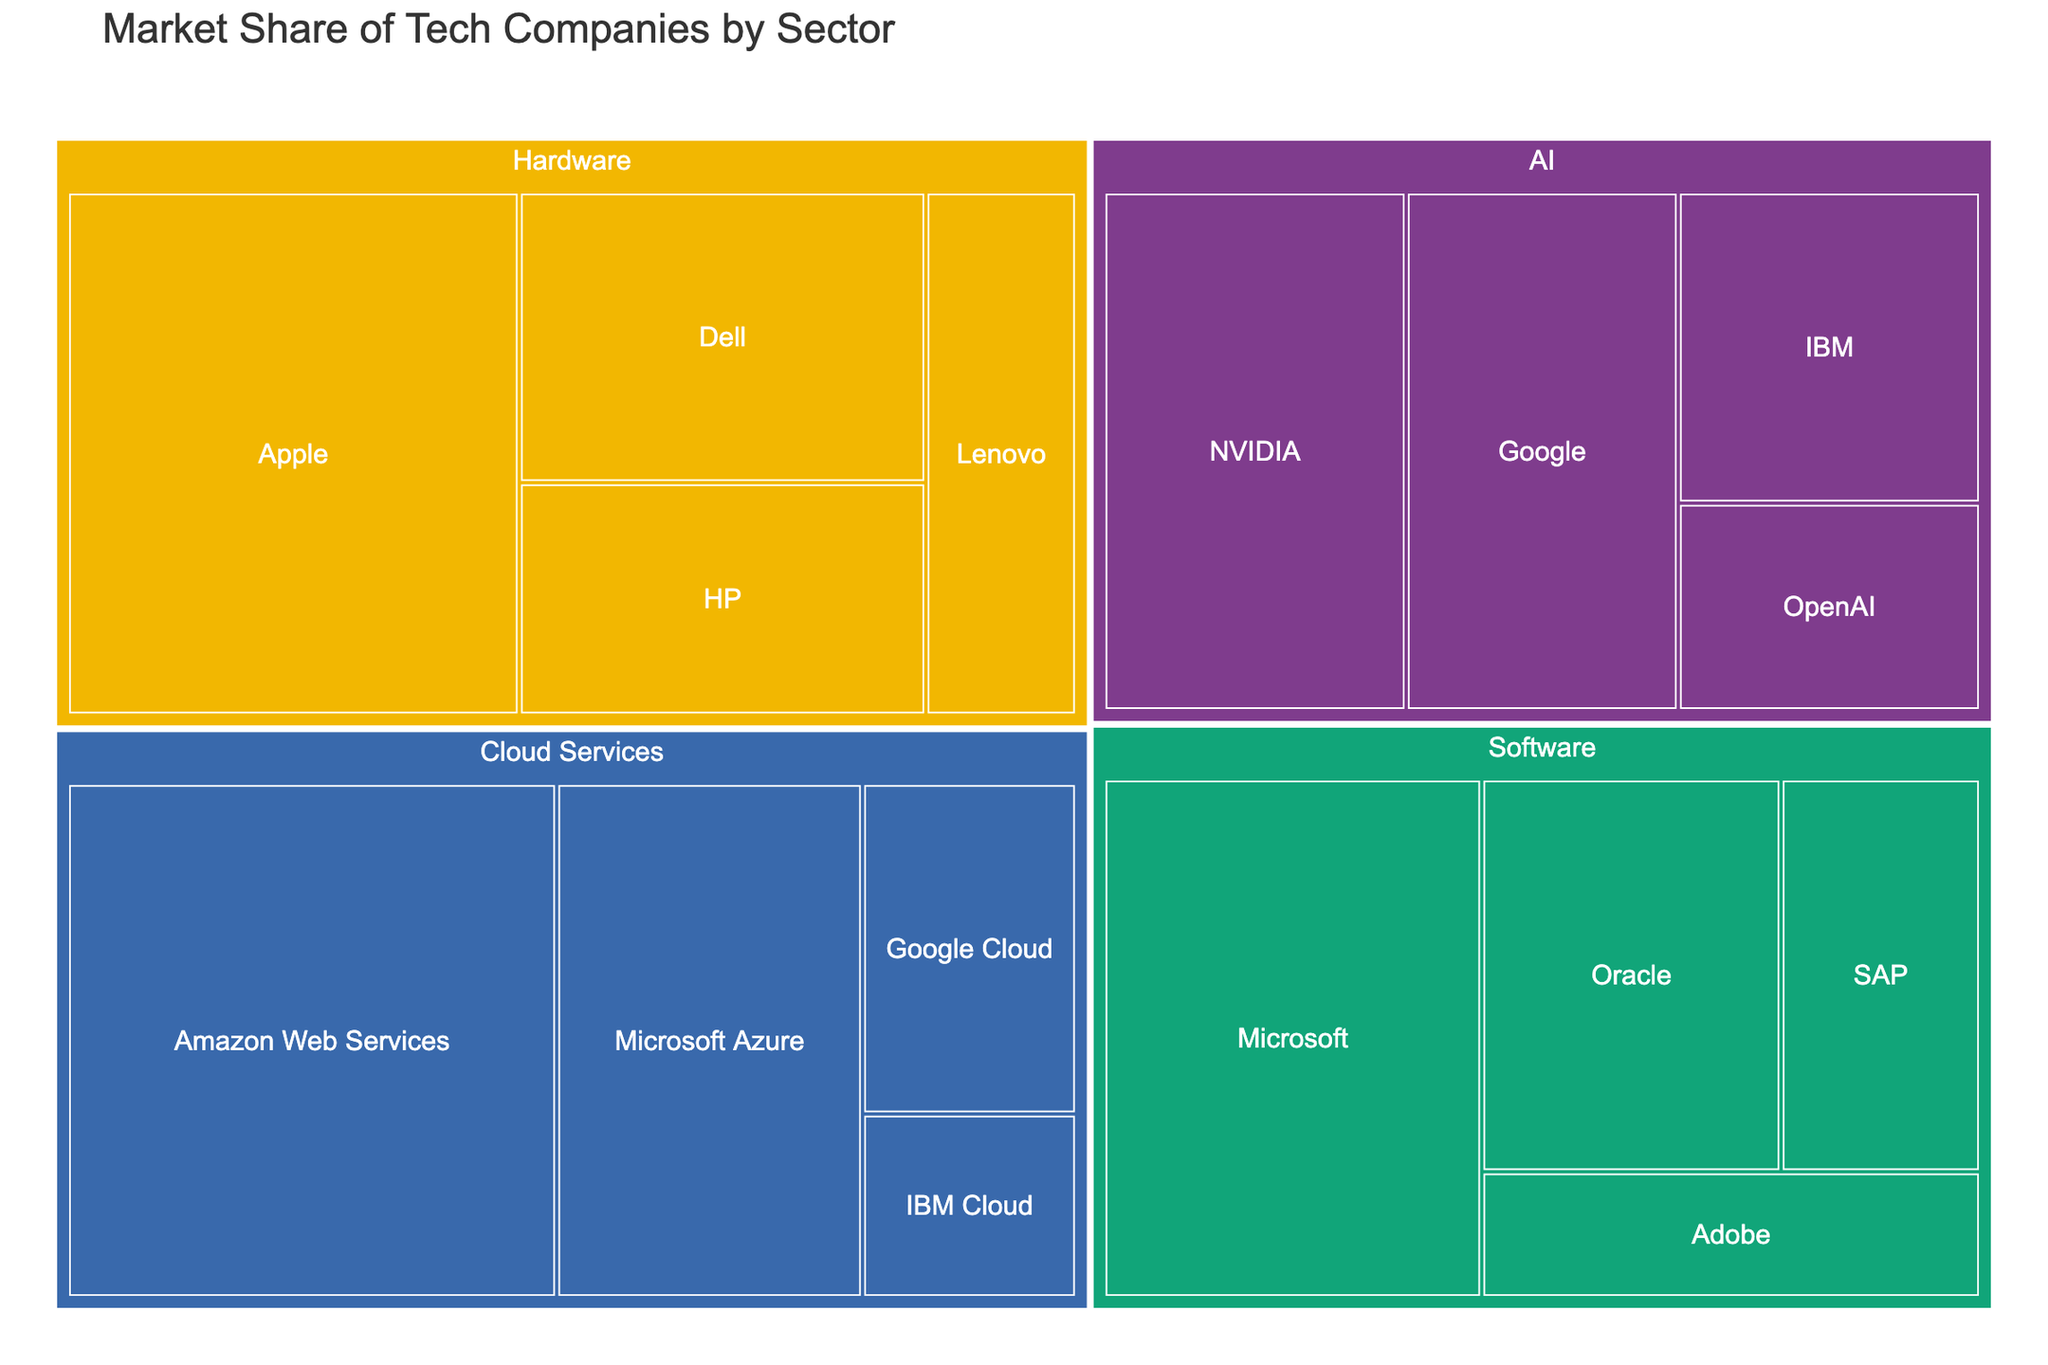what is the title of the plot? The title is often found at the top of the plot and indicates what the plot is about. Here, it is "Market Share of Tech Companies by Sector".
Answer: Market Share of Tech Companies by Sector which company has the largest market share in the AI sector? Look for the AI sector in the treemap and then identify the company with the largest area within that sector. The company is NVIDIA with a 20% market share.
Answer: NVIDIA what is the combined market share of Apple and Dell in the Hardware sector? Locate the Hardware sector and identify the market shares of Apple (30%) and Dell (15%). Add these values together: 30% + 15% = 45%.
Answer: 45% which sector has the most companies represented? Count the number of companies in each sector. Software has four companies (Microsoft, Oracle, SAP, Adobe), which is the highest.
Answer: Software which company has a greater market share: Google Cloud or OpenAI? Compare the market shares of Google Cloud (9%) in Cloud Services and OpenAI (8%) in AI. Google Cloud has a greater market share.
Answer: Google Cloud how does Microsoft’s market share in Software compare to its market share in Cloud Services? Find Microsoft's market share in Software (25%) and compare it to its market share in Cloud Services (20%). Microsoft's market share in Software is higher.
Answer: Higher in Software what is the combined market share of all companies in the Cloud Services sector? Locate the Cloud Services sector and sum the market shares of Amazon Web Services (32%), Microsoft Azure (20%), Google Cloud (9%), and IBM Cloud (5%). The total is: 32% + 20% + 9% + 5% = 66%.
Answer: 66% is OpenAI's market share in the AI sector higher or lower than IBM's? Compare the market shares of OpenAI (8%) and IBM (12%) in the AI sector. OpenAI's market share is lower.
Answer: Lower which two companies have the closest market share in the Hardware sector? Compare the market shares within the Hardware sector: Apple (30%), Dell (15%), HP (12%), and Lenovo (10%). HP and Lenovo have the closest market shares (12% and 10%).
Answer: HP and Lenovo what is the range of market shares within the Software sector? Identify the highest and lowest market shares in the Software sector: Microsoft (25%) and Adobe (8%). The range is 25% - 8% = 17%.
Answer: 17% 